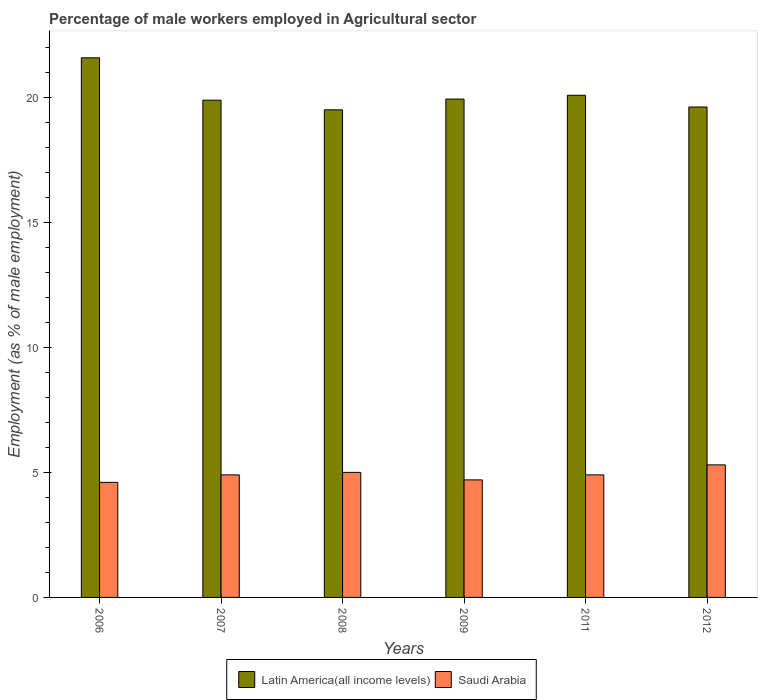How many different coloured bars are there?
Make the answer very short. 2. Are the number of bars on each tick of the X-axis equal?
Offer a terse response. Yes. How many bars are there on the 1st tick from the left?
Provide a succinct answer. 2. How many bars are there on the 3rd tick from the right?
Offer a terse response. 2. What is the label of the 3rd group of bars from the left?
Make the answer very short. 2008. What is the percentage of male workers employed in Agricultural sector in Latin America(all income levels) in 2012?
Keep it short and to the point. 19.61. Across all years, what is the maximum percentage of male workers employed in Agricultural sector in Latin America(all income levels)?
Your answer should be compact. 21.58. Across all years, what is the minimum percentage of male workers employed in Agricultural sector in Latin America(all income levels)?
Offer a terse response. 19.5. In which year was the percentage of male workers employed in Agricultural sector in Latin America(all income levels) maximum?
Keep it short and to the point. 2006. In which year was the percentage of male workers employed in Agricultural sector in Latin America(all income levels) minimum?
Offer a very short reply. 2008. What is the total percentage of male workers employed in Agricultural sector in Latin America(all income levels) in the graph?
Your answer should be compact. 120.58. What is the difference between the percentage of male workers employed in Agricultural sector in Saudi Arabia in 2006 and that in 2007?
Offer a very short reply. -0.3. What is the difference between the percentage of male workers employed in Agricultural sector in Saudi Arabia in 2007 and the percentage of male workers employed in Agricultural sector in Latin America(all income levels) in 2012?
Your answer should be very brief. -14.71. What is the average percentage of male workers employed in Agricultural sector in Saudi Arabia per year?
Your answer should be compact. 4.9. In the year 2011, what is the difference between the percentage of male workers employed in Agricultural sector in Latin America(all income levels) and percentage of male workers employed in Agricultural sector in Saudi Arabia?
Your answer should be very brief. 15.18. What is the ratio of the percentage of male workers employed in Agricultural sector in Latin America(all income levels) in 2006 to that in 2007?
Offer a very short reply. 1.09. Is the difference between the percentage of male workers employed in Agricultural sector in Latin America(all income levels) in 2008 and 2012 greater than the difference between the percentage of male workers employed in Agricultural sector in Saudi Arabia in 2008 and 2012?
Provide a succinct answer. Yes. What is the difference between the highest and the second highest percentage of male workers employed in Agricultural sector in Latin America(all income levels)?
Ensure brevity in your answer.  1.5. What is the difference between the highest and the lowest percentage of male workers employed in Agricultural sector in Saudi Arabia?
Your response must be concise. 0.7. What does the 2nd bar from the left in 2012 represents?
Your response must be concise. Saudi Arabia. What does the 2nd bar from the right in 2008 represents?
Your answer should be very brief. Latin America(all income levels). Are all the bars in the graph horizontal?
Your answer should be compact. No. Does the graph contain grids?
Provide a short and direct response. No. How many legend labels are there?
Make the answer very short. 2. How are the legend labels stacked?
Your answer should be very brief. Horizontal. What is the title of the graph?
Your response must be concise. Percentage of male workers employed in Agricultural sector. Does "Zambia" appear as one of the legend labels in the graph?
Your response must be concise. No. What is the label or title of the Y-axis?
Ensure brevity in your answer.  Employment (as % of male employment). What is the Employment (as % of male employment) of Latin America(all income levels) in 2006?
Keep it short and to the point. 21.58. What is the Employment (as % of male employment) of Saudi Arabia in 2006?
Your answer should be very brief. 4.6. What is the Employment (as % of male employment) in Latin America(all income levels) in 2007?
Offer a terse response. 19.88. What is the Employment (as % of male employment) of Saudi Arabia in 2007?
Ensure brevity in your answer.  4.9. What is the Employment (as % of male employment) of Latin America(all income levels) in 2008?
Provide a short and direct response. 19.5. What is the Employment (as % of male employment) of Latin America(all income levels) in 2009?
Your response must be concise. 19.93. What is the Employment (as % of male employment) in Saudi Arabia in 2009?
Provide a short and direct response. 4.7. What is the Employment (as % of male employment) in Latin America(all income levels) in 2011?
Give a very brief answer. 20.08. What is the Employment (as % of male employment) of Saudi Arabia in 2011?
Offer a very short reply. 4.9. What is the Employment (as % of male employment) of Latin America(all income levels) in 2012?
Your answer should be very brief. 19.61. What is the Employment (as % of male employment) of Saudi Arabia in 2012?
Keep it short and to the point. 5.3. Across all years, what is the maximum Employment (as % of male employment) in Latin America(all income levels)?
Offer a terse response. 21.58. Across all years, what is the maximum Employment (as % of male employment) of Saudi Arabia?
Provide a short and direct response. 5.3. Across all years, what is the minimum Employment (as % of male employment) of Latin America(all income levels)?
Provide a short and direct response. 19.5. Across all years, what is the minimum Employment (as % of male employment) in Saudi Arabia?
Offer a very short reply. 4.6. What is the total Employment (as % of male employment) of Latin America(all income levels) in the graph?
Provide a short and direct response. 120.58. What is the total Employment (as % of male employment) in Saudi Arabia in the graph?
Give a very brief answer. 29.4. What is the difference between the Employment (as % of male employment) in Latin America(all income levels) in 2006 and that in 2007?
Your answer should be compact. 1.7. What is the difference between the Employment (as % of male employment) in Latin America(all income levels) in 2006 and that in 2008?
Keep it short and to the point. 2.08. What is the difference between the Employment (as % of male employment) in Latin America(all income levels) in 2006 and that in 2009?
Ensure brevity in your answer.  1.65. What is the difference between the Employment (as % of male employment) of Saudi Arabia in 2006 and that in 2009?
Offer a terse response. -0.1. What is the difference between the Employment (as % of male employment) in Latin America(all income levels) in 2006 and that in 2011?
Offer a terse response. 1.5. What is the difference between the Employment (as % of male employment) in Latin America(all income levels) in 2006 and that in 2012?
Offer a very short reply. 1.97. What is the difference between the Employment (as % of male employment) in Latin America(all income levels) in 2007 and that in 2008?
Provide a succinct answer. 0.39. What is the difference between the Employment (as % of male employment) of Latin America(all income levels) in 2007 and that in 2009?
Provide a succinct answer. -0.04. What is the difference between the Employment (as % of male employment) in Saudi Arabia in 2007 and that in 2009?
Ensure brevity in your answer.  0.2. What is the difference between the Employment (as % of male employment) of Latin America(all income levels) in 2007 and that in 2011?
Provide a short and direct response. -0.2. What is the difference between the Employment (as % of male employment) in Latin America(all income levels) in 2007 and that in 2012?
Your answer should be very brief. 0.27. What is the difference between the Employment (as % of male employment) of Saudi Arabia in 2007 and that in 2012?
Give a very brief answer. -0.4. What is the difference between the Employment (as % of male employment) in Latin America(all income levels) in 2008 and that in 2009?
Offer a terse response. -0.43. What is the difference between the Employment (as % of male employment) of Latin America(all income levels) in 2008 and that in 2011?
Give a very brief answer. -0.58. What is the difference between the Employment (as % of male employment) in Saudi Arabia in 2008 and that in 2011?
Your answer should be very brief. 0.1. What is the difference between the Employment (as % of male employment) in Latin America(all income levels) in 2008 and that in 2012?
Provide a succinct answer. -0.11. What is the difference between the Employment (as % of male employment) in Saudi Arabia in 2008 and that in 2012?
Your answer should be very brief. -0.3. What is the difference between the Employment (as % of male employment) of Latin America(all income levels) in 2009 and that in 2011?
Keep it short and to the point. -0.15. What is the difference between the Employment (as % of male employment) of Latin America(all income levels) in 2009 and that in 2012?
Ensure brevity in your answer.  0.32. What is the difference between the Employment (as % of male employment) of Latin America(all income levels) in 2011 and that in 2012?
Ensure brevity in your answer.  0.47. What is the difference between the Employment (as % of male employment) of Saudi Arabia in 2011 and that in 2012?
Provide a short and direct response. -0.4. What is the difference between the Employment (as % of male employment) of Latin America(all income levels) in 2006 and the Employment (as % of male employment) of Saudi Arabia in 2007?
Your response must be concise. 16.68. What is the difference between the Employment (as % of male employment) in Latin America(all income levels) in 2006 and the Employment (as % of male employment) in Saudi Arabia in 2008?
Ensure brevity in your answer.  16.58. What is the difference between the Employment (as % of male employment) of Latin America(all income levels) in 2006 and the Employment (as % of male employment) of Saudi Arabia in 2009?
Give a very brief answer. 16.88. What is the difference between the Employment (as % of male employment) in Latin America(all income levels) in 2006 and the Employment (as % of male employment) in Saudi Arabia in 2011?
Provide a short and direct response. 16.68. What is the difference between the Employment (as % of male employment) of Latin America(all income levels) in 2006 and the Employment (as % of male employment) of Saudi Arabia in 2012?
Make the answer very short. 16.28. What is the difference between the Employment (as % of male employment) of Latin America(all income levels) in 2007 and the Employment (as % of male employment) of Saudi Arabia in 2008?
Offer a terse response. 14.88. What is the difference between the Employment (as % of male employment) of Latin America(all income levels) in 2007 and the Employment (as % of male employment) of Saudi Arabia in 2009?
Provide a succinct answer. 15.18. What is the difference between the Employment (as % of male employment) of Latin America(all income levels) in 2007 and the Employment (as % of male employment) of Saudi Arabia in 2011?
Your answer should be compact. 14.98. What is the difference between the Employment (as % of male employment) in Latin America(all income levels) in 2007 and the Employment (as % of male employment) in Saudi Arabia in 2012?
Your answer should be compact. 14.58. What is the difference between the Employment (as % of male employment) in Latin America(all income levels) in 2008 and the Employment (as % of male employment) in Saudi Arabia in 2009?
Your response must be concise. 14.8. What is the difference between the Employment (as % of male employment) in Latin America(all income levels) in 2008 and the Employment (as % of male employment) in Saudi Arabia in 2011?
Your answer should be compact. 14.6. What is the difference between the Employment (as % of male employment) of Latin America(all income levels) in 2008 and the Employment (as % of male employment) of Saudi Arabia in 2012?
Your response must be concise. 14.2. What is the difference between the Employment (as % of male employment) in Latin America(all income levels) in 2009 and the Employment (as % of male employment) in Saudi Arabia in 2011?
Offer a terse response. 15.03. What is the difference between the Employment (as % of male employment) of Latin America(all income levels) in 2009 and the Employment (as % of male employment) of Saudi Arabia in 2012?
Offer a terse response. 14.63. What is the difference between the Employment (as % of male employment) in Latin America(all income levels) in 2011 and the Employment (as % of male employment) in Saudi Arabia in 2012?
Your answer should be very brief. 14.78. What is the average Employment (as % of male employment) in Latin America(all income levels) per year?
Keep it short and to the point. 20.1. In the year 2006, what is the difference between the Employment (as % of male employment) of Latin America(all income levels) and Employment (as % of male employment) of Saudi Arabia?
Make the answer very short. 16.98. In the year 2007, what is the difference between the Employment (as % of male employment) of Latin America(all income levels) and Employment (as % of male employment) of Saudi Arabia?
Your answer should be compact. 14.98. In the year 2008, what is the difference between the Employment (as % of male employment) of Latin America(all income levels) and Employment (as % of male employment) of Saudi Arabia?
Your answer should be very brief. 14.5. In the year 2009, what is the difference between the Employment (as % of male employment) in Latin America(all income levels) and Employment (as % of male employment) in Saudi Arabia?
Make the answer very short. 15.23. In the year 2011, what is the difference between the Employment (as % of male employment) in Latin America(all income levels) and Employment (as % of male employment) in Saudi Arabia?
Your answer should be compact. 15.18. In the year 2012, what is the difference between the Employment (as % of male employment) in Latin America(all income levels) and Employment (as % of male employment) in Saudi Arabia?
Offer a very short reply. 14.31. What is the ratio of the Employment (as % of male employment) in Latin America(all income levels) in 2006 to that in 2007?
Your answer should be very brief. 1.09. What is the ratio of the Employment (as % of male employment) of Saudi Arabia in 2006 to that in 2007?
Offer a terse response. 0.94. What is the ratio of the Employment (as % of male employment) in Latin America(all income levels) in 2006 to that in 2008?
Offer a terse response. 1.11. What is the ratio of the Employment (as % of male employment) of Saudi Arabia in 2006 to that in 2008?
Provide a succinct answer. 0.92. What is the ratio of the Employment (as % of male employment) in Latin America(all income levels) in 2006 to that in 2009?
Your response must be concise. 1.08. What is the ratio of the Employment (as % of male employment) of Saudi Arabia in 2006 to that in 2009?
Offer a terse response. 0.98. What is the ratio of the Employment (as % of male employment) in Latin America(all income levels) in 2006 to that in 2011?
Provide a succinct answer. 1.07. What is the ratio of the Employment (as % of male employment) of Saudi Arabia in 2006 to that in 2011?
Make the answer very short. 0.94. What is the ratio of the Employment (as % of male employment) in Latin America(all income levels) in 2006 to that in 2012?
Ensure brevity in your answer.  1.1. What is the ratio of the Employment (as % of male employment) of Saudi Arabia in 2006 to that in 2012?
Give a very brief answer. 0.87. What is the ratio of the Employment (as % of male employment) in Latin America(all income levels) in 2007 to that in 2008?
Offer a terse response. 1.02. What is the ratio of the Employment (as % of male employment) in Saudi Arabia in 2007 to that in 2008?
Provide a succinct answer. 0.98. What is the ratio of the Employment (as % of male employment) in Latin America(all income levels) in 2007 to that in 2009?
Your answer should be very brief. 1. What is the ratio of the Employment (as % of male employment) of Saudi Arabia in 2007 to that in 2009?
Your response must be concise. 1.04. What is the ratio of the Employment (as % of male employment) in Latin America(all income levels) in 2007 to that in 2011?
Provide a succinct answer. 0.99. What is the ratio of the Employment (as % of male employment) in Saudi Arabia in 2007 to that in 2011?
Provide a short and direct response. 1. What is the ratio of the Employment (as % of male employment) in Latin America(all income levels) in 2007 to that in 2012?
Offer a terse response. 1.01. What is the ratio of the Employment (as % of male employment) in Saudi Arabia in 2007 to that in 2012?
Your answer should be very brief. 0.92. What is the ratio of the Employment (as % of male employment) in Latin America(all income levels) in 2008 to that in 2009?
Keep it short and to the point. 0.98. What is the ratio of the Employment (as % of male employment) of Saudi Arabia in 2008 to that in 2009?
Give a very brief answer. 1.06. What is the ratio of the Employment (as % of male employment) in Latin America(all income levels) in 2008 to that in 2011?
Provide a succinct answer. 0.97. What is the ratio of the Employment (as % of male employment) of Saudi Arabia in 2008 to that in 2011?
Your answer should be very brief. 1.02. What is the ratio of the Employment (as % of male employment) of Saudi Arabia in 2008 to that in 2012?
Your response must be concise. 0.94. What is the ratio of the Employment (as % of male employment) in Saudi Arabia in 2009 to that in 2011?
Ensure brevity in your answer.  0.96. What is the ratio of the Employment (as % of male employment) in Latin America(all income levels) in 2009 to that in 2012?
Ensure brevity in your answer.  1.02. What is the ratio of the Employment (as % of male employment) in Saudi Arabia in 2009 to that in 2012?
Your response must be concise. 0.89. What is the ratio of the Employment (as % of male employment) in Latin America(all income levels) in 2011 to that in 2012?
Your answer should be compact. 1.02. What is the ratio of the Employment (as % of male employment) of Saudi Arabia in 2011 to that in 2012?
Offer a very short reply. 0.92. What is the difference between the highest and the second highest Employment (as % of male employment) in Latin America(all income levels)?
Your response must be concise. 1.5. What is the difference between the highest and the lowest Employment (as % of male employment) of Latin America(all income levels)?
Ensure brevity in your answer.  2.08. What is the difference between the highest and the lowest Employment (as % of male employment) of Saudi Arabia?
Your answer should be very brief. 0.7. 